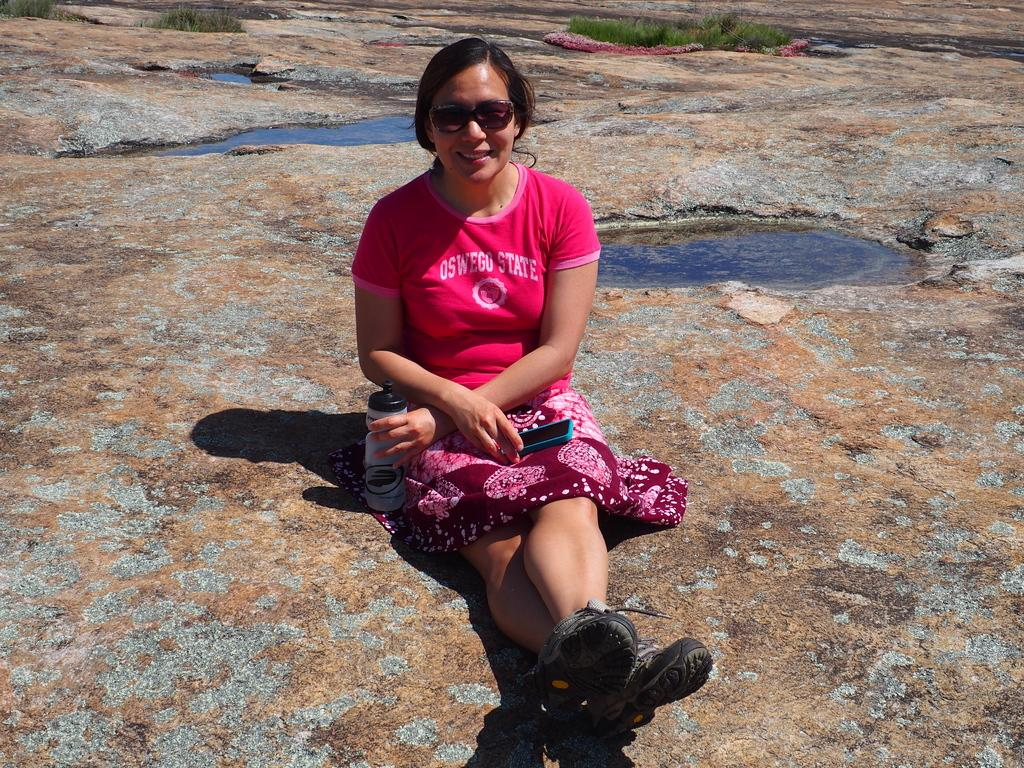Who is the main subject in the image? There is a woman in the image. What is the woman doing in the image? The woman is sitting. What objects is the woman holding in the image? The woman is holding a bottle and a mobile. What can be seen behind the woman in the image? There is water and grass visible behind the woman. What type of unit can be seen in the image? There is no unit present in the image. How does the acoustics of the woman's voice change in the image? The image does not provide any information about the acoustics of the woman's voice. 